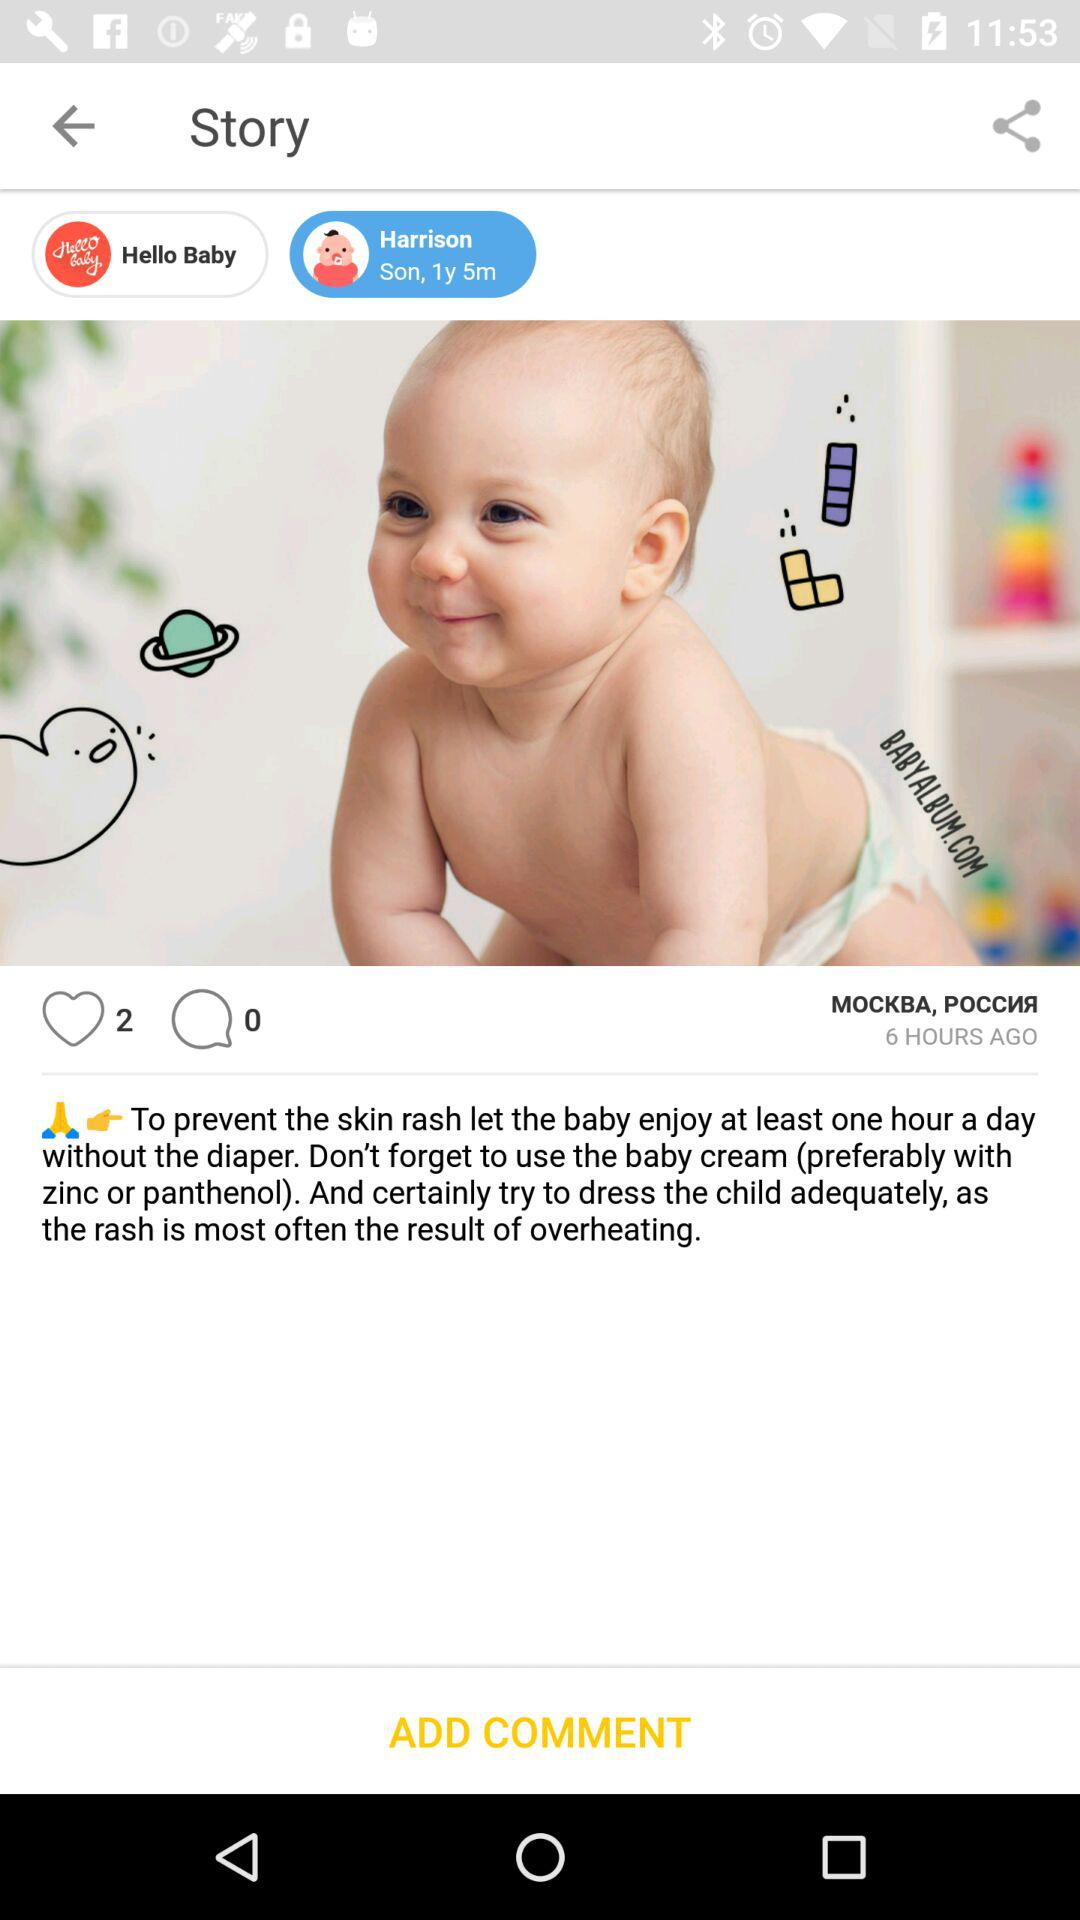How many hours ago was this story posted?
Answer the question using a single word or phrase. 6 hours ago 